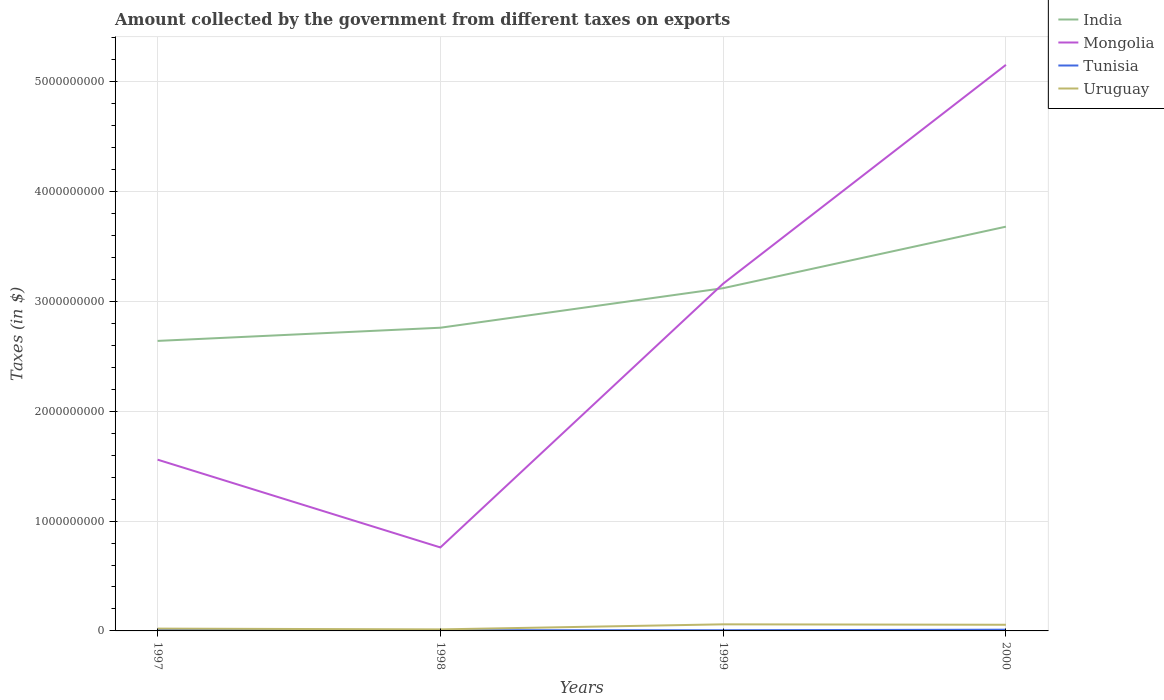Does the line corresponding to Uruguay intersect with the line corresponding to Tunisia?
Your answer should be compact. No. Across all years, what is the maximum amount collected by the government from taxes on exports in Uruguay?
Provide a succinct answer. 1.40e+07. In which year was the amount collected by the government from taxes on exports in Mongolia maximum?
Provide a succinct answer. 1998. What is the total amount collected by the government from taxes on exports in Mongolia in the graph?
Make the answer very short. 7.99e+08. How many lines are there?
Your answer should be compact. 4. How many years are there in the graph?
Offer a very short reply. 4. What is the difference between two consecutive major ticks on the Y-axis?
Provide a short and direct response. 1.00e+09. Are the values on the major ticks of Y-axis written in scientific E-notation?
Make the answer very short. No. Does the graph contain grids?
Provide a short and direct response. Yes. How many legend labels are there?
Provide a short and direct response. 4. What is the title of the graph?
Offer a terse response. Amount collected by the government from different taxes on exports. What is the label or title of the X-axis?
Your answer should be very brief. Years. What is the label or title of the Y-axis?
Keep it short and to the point. Taxes (in $). What is the Taxes (in $) in India in 1997?
Provide a succinct answer. 2.64e+09. What is the Taxes (in $) of Mongolia in 1997?
Keep it short and to the point. 1.56e+09. What is the Taxes (in $) in Tunisia in 1997?
Give a very brief answer. 1.02e+07. What is the Taxes (in $) of Uruguay in 1997?
Your response must be concise. 2.10e+07. What is the Taxes (in $) of India in 1998?
Keep it short and to the point. 2.76e+09. What is the Taxes (in $) in Mongolia in 1998?
Give a very brief answer. 7.60e+08. What is the Taxes (in $) of Tunisia in 1998?
Keep it short and to the point. 6.70e+06. What is the Taxes (in $) of Uruguay in 1998?
Ensure brevity in your answer.  1.40e+07. What is the Taxes (in $) of India in 1999?
Ensure brevity in your answer.  3.12e+09. What is the Taxes (in $) in Mongolia in 1999?
Offer a terse response. 3.16e+09. What is the Taxes (in $) of Tunisia in 1999?
Offer a very short reply. 6.20e+06. What is the Taxes (in $) in Uruguay in 1999?
Ensure brevity in your answer.  6.00e+07. What is the Taxes (in $) in India in 2000?
Your response must be concise. 3.68e+09. What is the Taxes (in $) of Mongolia in 2000?
Provide a short and direct response. 5.15e+09. What is the Taxes (in $) in Tunisia in 2000?
Your answer should be compact. 1.12e+07. What is the Taxes (in $) in Uruguay in 2000?
Keep it short and to the point. 5.60e+07. Across all years, what is the maximum Taxes (in $) in India?
Ensure brevity in your answer.  3.68e+09. Across all years, what is the maximum Taxes (in $) in Mongolia?
Make the answer very short. 5.15e+09. Across all years, what is the maximum Taxes (in $) of Tunisia?
Keep it short and to the point. 1.12e+07. Across all years, what is the maximum Taxes (in $) of Uruguay?
Your answer should be compact. 6.00e+07. Across all years, what is the minimum Taxes (in $) in India?
Ensure brevity in your answer.  2.64e+09. Across all years, what is the minimum Taxes (in $) of Mongolia?
Your answer should be compact. 7.60e+08. Across all years, what is the minimum Taxes (in $) in Tunisia?
Offer a very short reply. 6.20e+06. Across all years, what is the minimum Taxes (in $) of Uruguay?
Give a very brief answer. 1.40e+07. What is the total Taxes (in $) in India in the graph?
Offer a very short reply. 1.22e+1. What is the total Taxes (in $) of Mongolia in the graph?
Provide a short and direct response. 1.06e+1. What is the total Taxes (in $) in Tunisia in the graph?
Provide a short and direct response. 3.43e+07. What is the total Taxes (in $) of Uruguay in the graph?
Provide a succinct answer. 1.51e+08. What is the difference between the Taxes (in $) of India in 1997 and that in 1998?
Provide a short and direct response. -1.20e+08. What is the difference between the Taxes (in $) in Mongolia in 1997 and that in 1998?
Provide a succinct answer. 7.99e+08. What is the difference between the Taxes (in $) in Tunisia in 1997 and that in 1998?
Your response must be concise. 3.50e+06. What is the difference between the Taxes (in $) in Uruguay in 1997 and that in 1998?
Offer a terse response. 7.00e+06. What is the difference between the Taxes (in $) of India in 1997 and that in 1999?
Your answer should be very brief. -4.80e+08. What is the difference between the Taxes (in $) of Mongolia in 1997 and that in 1999?
Provide a short and direct response. -1.60e+09. What is the difference between the Taxes (in $) of Tunisia in 1997 and that in 1999?
Make the answer very short. 4.00e+06. What is the difference between the Taxes (in $) in Uruguay in 1997 and that in 1999?
Make the answer very short. -3.90e+07. What is the difference between the Taxes (in $) in India in 1997 and that in 2000?
Ensure brevity in your answer.  -1.04e+09. What is the difference between the Taxes (in $) in Mongolia in 1997 and that in 2000?
Your answer should be very brief. -3.59e+09. What is the difference between the Taxes (in $) of Uruguay in 1997 and that in 2000?
Provide a succinct answer. -3.50e+07. What is the difference between the Taxes (in $) of India in 1998 and that in 1999?
Your response must be concise. -3.60e+08. What is the difference between the Taxes (in $) in Mongolia in 1998 and that in 1999?
Provide a short and direct response. -2.40e+09. What is the difference between the Taxes (in $) of Tunisia in 1998 and that in 1999?
Offer a very short reply. 5.00e+05. What is the difference between the Taxes (in $) of Uruguay in 1998 and that in 1999?
Provide a short and direct response. -4.60e+07. What is the difference between the Taxes (in $) in India in 1998 and that in 2000?
Provide a succinct answer. -9.20e+08. What is the difference between the Taxes (in $) of Mongolia in 1998 and that in 2000?
Ensure brevity in your answer.  -4.39e+09. What is the difference between the Taxes (in $) in Tunisia in 1998 and that in 2000?
Provide a succinct answer. -4.50e+06. What is the difference between the Taxes (in $) of Uruguay in 1998 and that in 2000?
Keep it short and to the point. -4.20e+07. What is the difference between the Taxes (in $) of India in 1999 and that in 2000?
Your answer should be very brief. -5.60e+08. What is the difference between the Taxes (in $) of Mongolia in 1999 and that in 2000?
Your answer should be very brief. -1.99e+09. What is the difference between the Taxes (in $) in Tunisia in 1999 and that in 2000?
Make the answer very short. -5.00e+06. What is the difference between the Taxes (in $) of India in 1997 and the Taxes (in $) of Mongolia in 1998?
Keep it short and to the point. 1.88e+09. What is the difference between the Taxes (in $) in India in 1997 and the Taxes (in $) in Tunisia in 1998?
Provide a short and direct response. 2.63e+09. What is the difference between the Taxes (in $) of India in 1997 and the Taxes (in $) of Uruguay in 1998?
Your response must be concise. 2.63e+09. What is the difference between the Taxes (in $) of Mongolia in 1997 and the Taxes (in $) of Tunisia in 1998?
Offer a terse response. 1.55e+09. What is the difference between the Taxes (in $) in Mongolia in 1997 and the Taxes (in $) in Uruguay in 1998?
Provide a succinct answer. 1.54e+09. What is the difference between the Taxes (in $) of Tunisia in 1997 and the Taxes (in $) of Uruguay in 1998?
Your answer should be compact. -3.80e+06. What is the difference between the Taxes (in $) in India in 1997 and the Taxes (in $) in Mongolia in 1999?
Your answer should be very brief. -5.21e+08. What is the difference between the Taxes (in $) of India in 1997 and the Taxes (in $) of Tunisia in 1999?
Offer a very short reply. 2.63e+09. What is the difference between the Taxes (in $) in India in 1997 and the Taxes (in $) in Uruguay in 1999?
Your answer should be very brief. 2.58e+09. What is the difference between the Taxes (in $) of Mongolia in 1997 and the Taxes (in $) of Tunisia in 1999?
Your response must be concise. 1.55e+09. What is the difference between the Taxes (in $) in Mongolia in 1997 and the Taxes (in $) in Uruguay in 1999?
Your response must be concise. 1.50e+09. What is the difference between the Taxes (in $) of Tunisia in 1997 and the Taxes (in $) of Uruguay in 1999?
Your answer should be very brief. -4.98e+07. What is the difference between the Taxes (in $) in India in 1997 and the Taxes (in $) in Mongolia in 2000?
Provide a succinct answer. -2.51e+09. What is the difference between the Taxes (in $) in India in 1997 and the Taxes (in $) in Tunisia in 2000?
Provide a succinct answer. 2.63e+09. What is the difference between the Taxes (in $) in India in 1997 and the Taxes (in $) in Uruguay in 2000?
Your answer should be compact. 2.58e+09. What is the difference between the Taxes (in $) in Mongolia in 1997 and the Taxes (in $) in Tunisia in 2000?
Give a very brief answer. 1.55e+09. What is the difference between the Taxes (in $) of Mongolia in 1997 and the Taxes (in $) of Uruguay in 2000?
Give a very brief answer. 1.50e+09. What is the difference between the Taxes (in $) of Tunisia in 1997 and the Taxes (in $) of Uruguay in 2000?
Provide a succinct answer. -4.58e+07. What is the difference between the Taxes (in $) of India in 1998 and the Taxes (in $) of Mongolia in 1999?
Ensure brevity in your answer.  -4.01e+08. What is the difference between the Taxes (in $) of India in 1998 and the Taxes (in $) of Tunisia in 1999?
Offer a very short reply. 2.75e+09. What is the difference between the Taxes (in $) of India in 1998 and the Taxes (in $) of Uruguay in 1999?
Your answer should be very brief. 2.70e+09. What is the difference between the Taxes (in $) in Mongolia in 1998 and the Taxes (in $) in Tunisia in 1999?
Your answer should be very brief. 7.54e+08. What is the difference between the Taxes (in $) in Mongolia in 1998 and the Taxes (in $) in Uruguay in 1999?
Ensure brevity in your answer.  7.00e+08. What is the difference between the Taxes (in $) of Tunisia in 1998 and the Taxes (in $) of Uruguay in 1999?
Give a very brief answer. -5.33e+07. What is the difference between the Taxes (in $) of India in 1998 and the Taxes (in $) of Mongolia in 2000?
Provide a short and direct response. -2.39e+09. What is the difference between the Taxes (in $) of India in 1998 and the Taxes (in $) of Tunisia in 2000?
Offer a very short reply. 2.75e+09. What is the difference between the Taxes (in $) in India in 1998 and the Taxes (in $) in Uruguay in 2000?
Your answer should be very brief. 2.70e+09. What is the difference between the Taxes (in $) in Mongolia in 1998 and the Taxes (in $) in Tunisia in 2000?
Provide a short and direct response. 7.49e+08. What is the difference between the Taxes (in $) in Mongolia in 1998 and the Taxes (in $) in Uruguay in 2000?
Make the answer very short. 7.04e+08. What is the difference between the Taxes (in $) in Tunisia in 1998 and the Taxes (in $) in Uruguay in 2000?
Provide a short and direct response. -4.93e+07. What is the difference between the Taxes (in $) in India in 1999 and the Taxes (in $) in Mongolia in 2000?
Provide a short and direct response. -2.03e+09. What is the difference between the Taxes (in $) of India in 1999 and the Taxes (in $) of Tunisia in 2000?
Provide a short and direct response. 3.11e+09. What is the difference between the Taxes (in $) in India in 1999 and the Taxes (in $) in Uruguay in 2000?
Make the answer very short. 3.06e+09. What is the difference between the Taxes (in $) of Mongolia in 1999 and the Taxes (in $) of Tunisia in 2000?
Provide a succinct answer. 3.15e+09. What is the difference between the Taxes (in $) in Mongolia in 1999 and the Taxes (in $) in Uruguay in 2000?
Offer a very short reply. 3.10e+09. What is the difference between the Taxes (in $) of Tunisia in 1999 and the Taxes (in $) of Uruguay in 2000?
Your answer should be compact. -4.98e+07. What is the average Taxes (in $) in India per year?
Provide a short and direct response. 3.05e+09. What is the average Taxes (in $) of Mongolia per year?
Keep it short and to the point. 2.66e+09. What is the average Taxes (in $) of Tunisia per year?
Your answer should be compact. 8.58e+06. What is the average Taxes (in $) of Uruguay per year?
Make the answer very short. 3.78e+07. In the year 1997, what is the difference between the Taxes (in $) in India and Taxes (in $) in Mongolia?
Keep it short and to the point. 1.08e+09. In the year 1997, what is the difference between the Taxes (in $) of India and Taxes (in $) of Tunisia?
Offer a terse response. 2.63e+09. In the year 1997, what is the difference between the Taxes (in $) in India and Taxes (in $) in Uruguay?
Provide a succinct answer. 2.62e+09. In the year 1997, what is the difference between the Taxes (in $) in Mongolia and Taxes (in $) in Tunisia?
Give a very brief answer. 1.55e+09. In the year 1997, what is the difference between the Taxes (in $) of Mongolia and Taxes (in $) of Uruguay?
Make the answer very short. 1.54e+09. In the year 1997, what is the difference between the Taxes (in $) in Tunisia and Taxes (in $) in Uruguay?
Your response must be concise. -1.08e+07. In the year 1998, what is the difference between the Taxes (in $) of India and Taxes (in $) of Mongolia?
Give a very brief answer. 2.00e+09. In the year 1998, what is the difference between the Taxes (in $) in India and Taxes (in $) in Tunisia?
Offer a very short reply. 2.75e+09. In the year 1998, what is the difference between the Taxes (in $) of India and Taxes (in $) of Uruguay?
Provide a short and direct response. 2.75e+09. In the year 1998, what is the difference between the Taxes (in $) of Mongolia and Taxes (in $) of Tunisia?
Your answer should be compact. 7.53e+08. In the year 1998, what is the difference between the Taxes (in $) of Mongolia and Taxes (in $) of Uruguay?
Provide a succinct answer. 7.46e+08. In the year 1998, what is the difference between the Taxes (in $) in Tunisia and Taxes (in $) in Uruguay?
Keep it short and to the point. -7.30e+06. In the year 1999, what is the difference between the Taxes (in $) in India and Taxes (in $) in Mongolia?
Your response must be concise. -4.10e+07. In the year 1999, what is the difference between the Taxes (in $) of India and Taxes (in $) of Tunisia?
Give a very brief answer. 3.11e+09. In the year 1999, what is the difference between the Taxes (in $) of India and Taxes (in $) of Uruguay?
Provide a succinct answer. 3.06e+09. In the year 1999, what is the difference between the Taxes (in $) of Mongolia and Taxes (in $) of Tunisia?
Offer a terse response. 3.15e+09. In the year 1999, what is the difference between the Taxes (in $) in Mongolia and Taxes (in $) in Uruguay?
Provide a short and direct response. 3.10e+09. In the year 1999, what is the difference between the Taxes (in $) in Tunisia and Taxes (in $) in Uruguay?
Ensure brevity in your answer.  -5.38e+07. In the year 2000, what is the difference between the Taxes (in $) in India and Taxes (in $) in Mongolia?
Your answer should be compact. -1.47e+09. In the year 2000, what is the difference between the Taxes (in $) of India and Taxes (in $) of Tunisia?
Make the answer very short. 3.67e+09. In the year 2000, what is the difference between the Taxes (in $) of India and Taxes (in $) of Uruguay?
Offer a terse response. 3.62e+09. In the year 2000, what is the difference between the Taxes (in $) of Mongolia and Taxes (in $) of Tunisia?
Your answer should be very brief. 5.14e+09. In the year 2000, what is the difference between the Taxes (in $) in Mongolia and Taxes (in $) in Uruguay?
Give a very brief answer. 5.10e+09. In the year 2000, what is the difference between the Taxes (in $) of Tunisia and Taxes (in $) of Uruguay?
Give a very brief answer. -4.48e+07. What is the ratio of the Taxes (in $) of India in 1997 to that in 1998?
Your answer should be compact. 0.96. What is the ratio of the Taxes (in $) in Mongolia in 1997 to that in 1998?
Your answer should be compact. 2.05. What is the ratio of the Taxes (in $) in Tunisia in 1997 to that in 1998?
Offer a terse response. 1.52. What is the ratio of the Taxes (in $) of India in 1997 to that in 1999?
Offer a very short reply. 0.85. What is the ratio of the Taxes (in $) in Mongolia in 1997 to that in 1999?
Offer a very short reply. 0.49. What is the ratio of the Taxes (in $) of Tunisia in 1997 to that in 1999?
Your answer should be compact. 1.65. What is the ratio of the Taxes (in $) in Uruguay in 1997 to that in 1999?
Your answer should be very brief. 0.35. What is the ratio of the Taxes (in $) in India in 1997 to that in 2000?
Your response must be concise. 0.72. What is the ratio of the Taxes (in $) of Mongolia in 1997 to that in 2000?
Give a very brief answer. 0.3. What is the ratio of the Taxes (in $) in Tunisia in 1997 to that in 2000?
Your answer should be very brief. 0.91. What is the ratio of the Taxes (in $) in India in 1998 to that in 1999?
Ensure brevity in your answer.  0.88. What is the ratio of the Taxes (in $) of Mongolia in 1998 to that in 1999?
Your response must be concise. 0.24. What is the ratio of the Taxes (in $) of Tunisia in 1998 to that in 1999?
Keep it short and to the point. 1.08. What is the ratio of the Taxes (in $) in Uruguay in 1998 to that in 1999?
Provide a short and direct response. 0.23. What is the ratio of the Taxes (in $) of India in 1998 to that in 2000?
Provide a short and direct response. 0.75. What is the ratio of the Taxes (in $) in Mongolia in 1998 to that in 2000?
Give a very brief answer. 0.15. What is the ratio of the Taxes (in $) of Tunisia in 1998 to that in 2000?
Your answer should be compact. 0.6. What is the ratio of the Taxes (in $) of India in 1999 to that in 2000?
Keep it short and to the point. 0.85. What is the ratio of the Taxes (in $) in Mongolia in 1999 to that in 2000?
Make the answer very short. 0.61. What is the ratio of the Taxes (in $) in Tunisia in 1999 to that in 2000?
Give a very brief answer. 0.55. What is the ratio of the Taxes (in $) of Uruguay in 1999 to that in 2000?
Offer a terse response. 1.07. What is the difference between the highest and the second highest Taxes (in $) of India?
Ensure brevity in your answer.  5.60e+08. What is the difference between the highest and the second highest Taxes (in $) of Mongolia?
Offer a very short reply. 1.99e+09. What is the difference between the highest and the second highest Taxes (in $) in Tunisia?
Give a very brief answer. 1.00e+06. What is the difference between the highest and the lowest Taxes (in $) in India?
Your response must be concise. 1.04e+09. What is the difference between the highest and the lowest Taxes (in $) in Mongolia?
Offer a terse response. 4.39e+09. What is the difference between the highest and the lowest Taxes (in $) of Tunisia?
Offer a very short reply. 5.00e+06. What is the difference between the highest and the lowest Taxes (in $) in Uruguay?
Provide a short and direct response. 4.60e+07. 